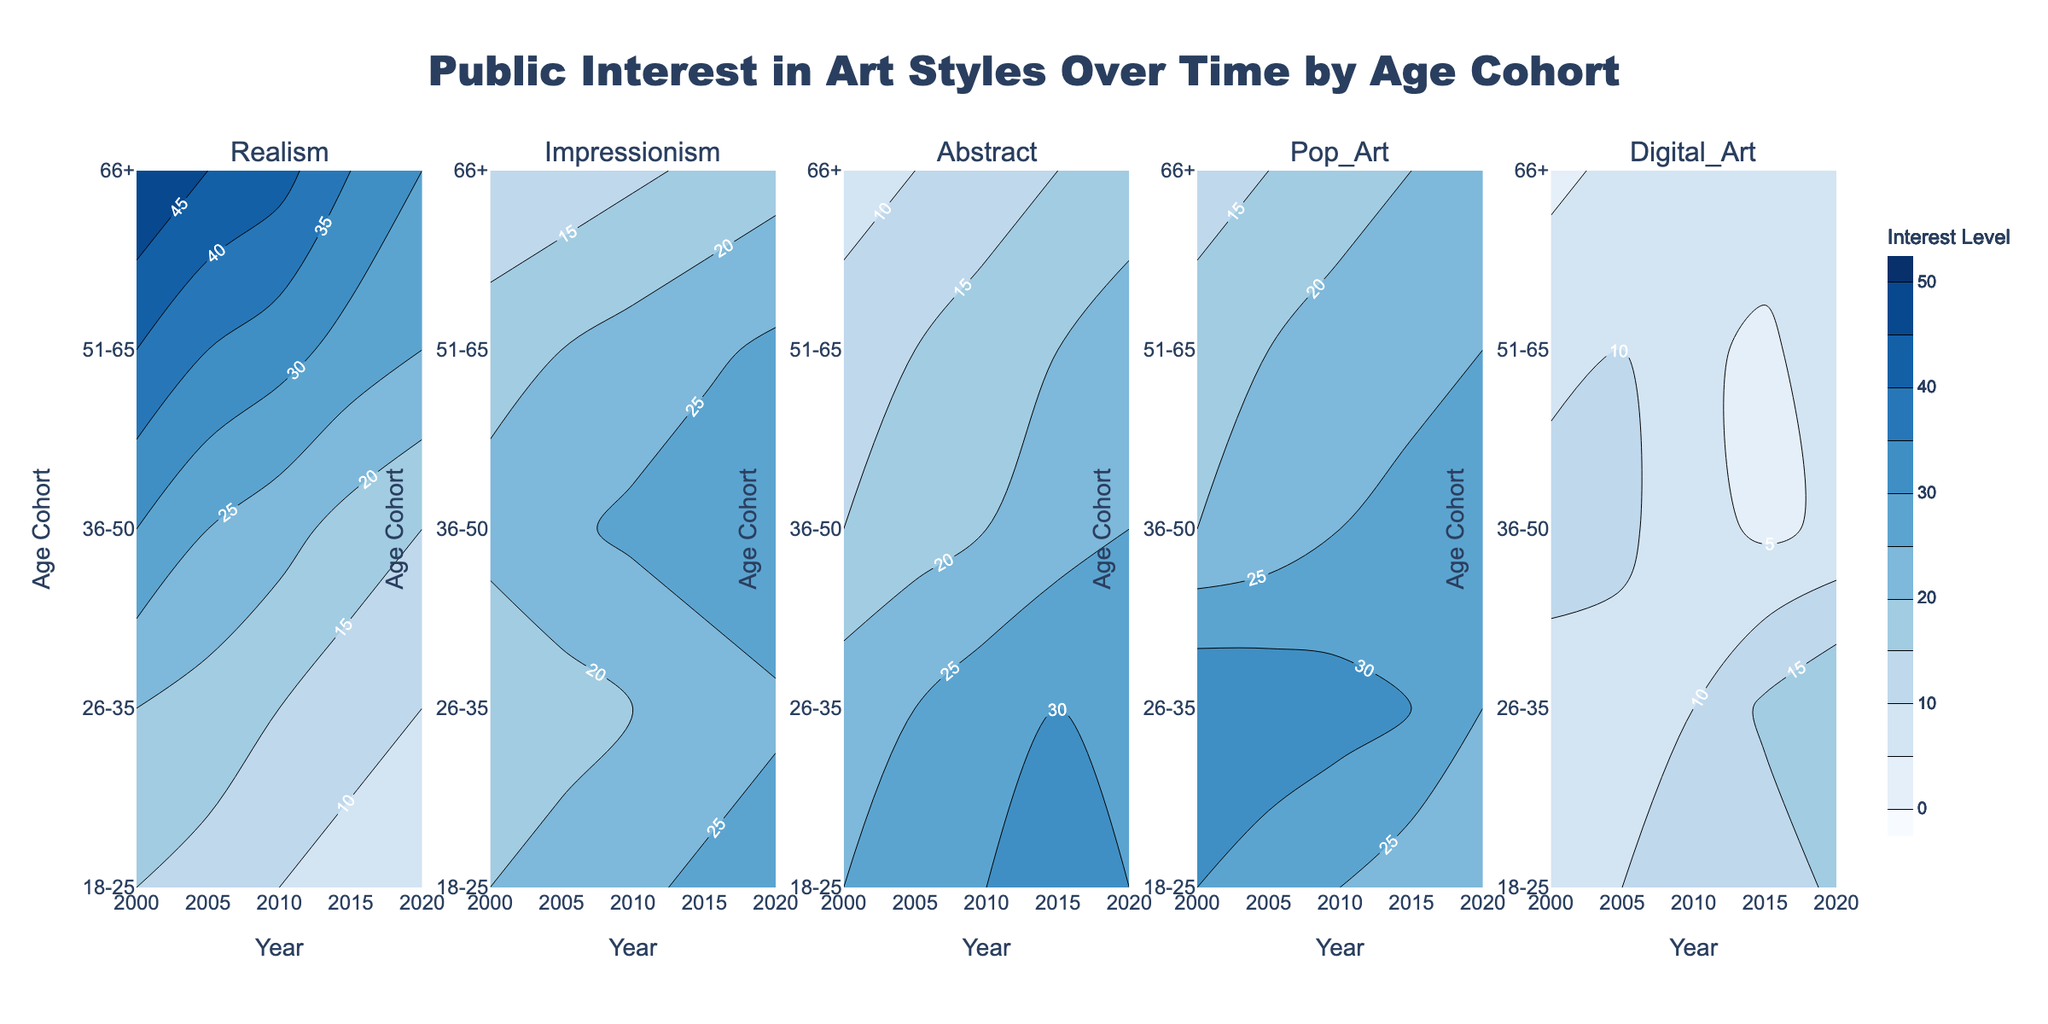Which age cohort had the highest interest in Realism in 2000? Look at the plot for Realism and examine the Y-axis to compare the contour levels for each age cohort in the year 2000. The highest contour level corresponds to the highest interest.
Answer: 66+ In which year did the 18-25 age cohort show the highest interest in Digital Art? Inspect the contour plot for Digital Art and trace the levels for the 18-25 age cohort. The highest contour level indicates the maximum interest point.
Answer: 2020 Which age cohort's interest in Abstract art consistently increased over the years shown? Examine the contour plot for Abstract art and follow the contours for each age cohort over time. The cohort with steadily increasing contour levels indicates increasing interest.
Answer: 51-65 Compare interest levels in Pop Art between the 36-50 and 26-35 age cohorts in 2015. Which cohort had higher interest? Check the contour plot for Pop Art, focus on the year 2015, and compare the contour levels between the 36-50 and 26-35 cohorts. The cohort with higher contour levels had higher interest.
Answer: 36-50 What is the overall trend in interest for Realism among the 18-25 age cohort from 2000 to 2020? In the contour plot for Realism, follow the contour levels for the 18-25 age cohort from 2000 to 2020. Observing the trend of the contour levels indicates whether interest increased, decreased or remained constant.
Answer: Decreasing How did the interest in Impressionism change for the 66+ age cohort from 2000 to 2005? Focus on the contour plot for Impressionism and compare the contour levels for the 66+ age cohort between 2000 and 2005. Determine the direction of the level change.
Answer: Increased Which art style did the 26-35 age cohort show the highest interest in, in 2020? By looking at the contour levels for each art style in 2020 for the 26-35 cohort, determine which contour level is the highest.
Answer: Digital Art What was the difference in interest levels for Digital Art between the 51-65 and 66+ age cohorts in 2010? Examine the contour plot for Digital Art, locate the contour levels for both age cohorts in 2010, and calculate the difference between the levels.
Answer: 1 In the year 2015, did the interest in Abstract art for the 18-25 age cohort exceed that of the 26-35 cohort? Check the contour plot for Abstract, comparing the levels for the 18-25 cohort and the 26-35 cohort in 2015. Determine if the contour level for the 18-25 cohort is higher.
Answer: Yes 